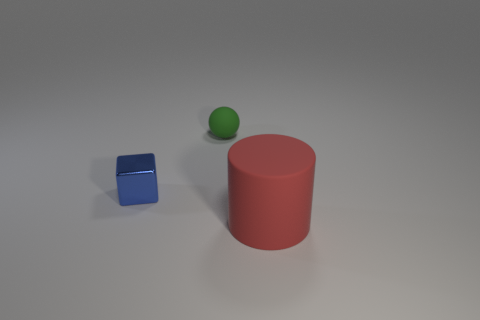Is there any other thing that has the same size as the cylinder?
Your answer should be compact. No. What is the color of the small thing in front of the rubber thing that is behind the large object?
Make the answer very short. Blue. What shape is the green rubber thing?
Offer a terse response. Sphere. There is a thing that is both behind the big rubber cylinder and in front of the green rubber object; what is its shape?
Your answer should be very brief. Cube. What color is the cylinder that is made of the same material as the green sphere?
Your answer should be compact. Red. There is a object that is in front of the tiny object that is to the left of the object behind the tiny blue metallic thing; what is its shape?
Your answer should be compact. Cylinder. The blue metallic cube is what size?
Your response must be concise. Small. There is a thing that is made of the same material as the cylinder; what shape is it?
Provide a succinct answer. Sphere. Are there fewer small balls behind the big red cylinder than tiny red shiny cubes?
Your answer should be compact. No. There is a rubber thing behind the big red thing; what is its color?
Ensure brevity in your answer.  Green. 